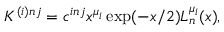<formula> <loc_0><loc_0><loc_500><loc_500>K ^ { ( i ) n j } = c ^ { i n j } x ^ { \mu _ { i } } \exp ( - x / 2 ) L _ { n } ^ { \mu _ { i } } ( x ) ,</formula> 